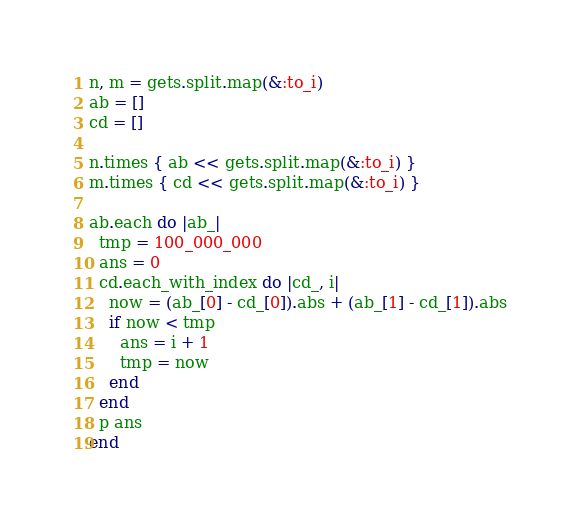<code> <loc_0><loc_0><loc_500><loc_500><_Ruby_>n, m = gets.split.map(&:to_i)
ab = []
cd = []

n.times { ab << gets.split.map(&:to_i) }
m.times { cd << gets.split.map(&:to_i) }

ab.each do |ab_|
  tmp = 100_000_000
  ans = 0
  cd.each_with_index do |cd_, i|
    now = (ab_[0] - cd_[0]).abs + (ab_[1] - cd_[1]).abs
    if now < tmp
      ans = i + 1
      tmp = now
    end
  end
  p ans
end</code> 